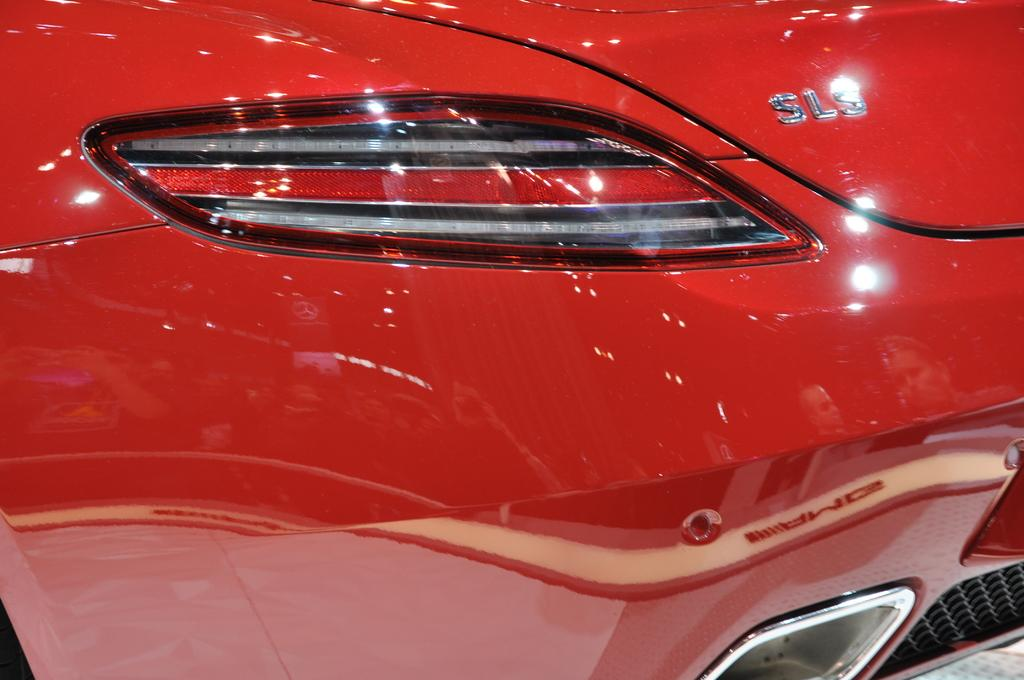What type of vehicle is in the image? There is a red color vehicle in the image. What specific feature does the vehicle have? The vehicle has lights. Are there any markings or text on the vehicle? Yes, there are letters on the vehicle. Can you see a friend holding an umbrella next to the vehicle in the image? There is no friend or umbrella present in the image; it only features a red color vehicle with lights and letters. Is there a tree growing near the vehicle in the image? There is no tree visible in the image; it only features a red color vehicle with lights and letters. 